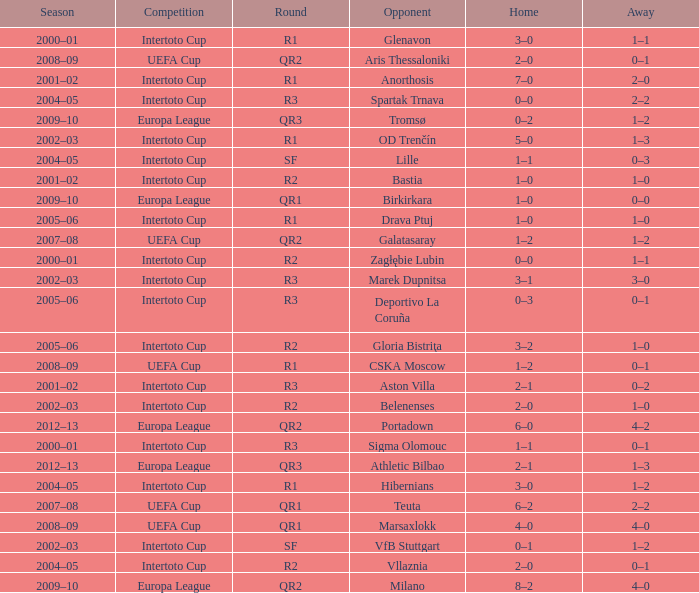What is the home score with marek dupnitsa as opponent? 3–1. Could you help me parse every detail presented in this table? {'header': ['Season', 'Competition', 'Round', 'Opponent', 'Home', 'Away'], 'rows': [['2000–01', 'Intertoto Cup', 'R1', 'Glenavon', '3–0', '1–1'], ['2008–09', 'UEFA Cup', 'QR2', 'Aris Thessaloniki', '2–0', '0–1'], ['2001–02', 'Intertoto Cup', 'R1', 'Anorthosis', '7–0', '2–0'], ['2004–05', 'Intertoto Cup', 'R3', 'Spartak Trnava', '0–0', '2–2'], ['2009–10', 'Europa League', 'QR3', 'Tromsø', '0–2', '1–2'], ['2002–03', 'Intertoto Cup', 'R1', 'OD Trenčín', '5–0', '1–3'], ['2004–05', 'Intertoto Cup', 'SF', 'Lille', '1–1', '0–3'], ['2001–02', 'Intertoto Cup', 'R2', 'Bastia', '1–0', '1–0'], ['2009–10', 'Europa League', 'QR1', 'Birkirkara', '1–0', '0–0'], ['2005–06', 'Intertoto Cup', 'R1', 'Drava Ptuj', '1–0', '1–0'], ['2007–08', 'UEFA Cup', 'QR2', 'Galatasaray', '1–2', '1–2'], ['2000–01', 'Intertoto Cup', 'R2', 'Zagłębie Lubin', '0–0', '1–1'], ['2002–03', 'Intertoto Cup', 'R3', 'Marek Dupnitsa', '3–1', '3–0'], ['2005–06', 'Intertoto Cup', 'R3', 'Deportivo La Coruña', '0–3', '0–1'], ['2005–06', 'Intertoto Cup', 'R2', 'Gloria Bistriţa', '3–2', '1–0'], ['2008–09', 'UEFA Cup', 'R1', 'CSKA Moscow', '1–2', '0–1'], ['2001–02', 'Intertoto Cup', 'R3', 'Aston Villa', '2–1', '0–2'], ['2002–03', 'Intertoto Cup', 'R2', 'Belenenses', '2–0', '1–0'], ['2012–13', 'Europa League', 'QR2', 'Portadown', '6–0', '4–2'], ['2000–01', 'Intertoto Cup', 'R3', 'Sigma Olomouc', '1–1', '0–1'], ['2012–13', 'Europa League', 'QR3', 'Athletic Bilbao', '2–1', '1–3'], ['2004–05', 'Intertoto Cup', 'R1', 'Hibernians', '3–0', '1–2'], ['2007–08', 'UEFA Cup', 'QR1', 'Teuta', '6–2', '2–2'], ['2008–09', 'UEFA Cup', 'QR1', 'Marsaxlokk', '4–0', '4–0'], ['2002–03', 'Intertoto Cup', 'SF', 'VfB Stuttgart', '0–1', '1–2'], ['2004–05', 'Intertoto Cup', 'R2', 'Vllaznia', '2–0', '0–1'], ['2009–10', 'Europa League', 'QR2', 'Milano', '8–2', '4–0']]} 